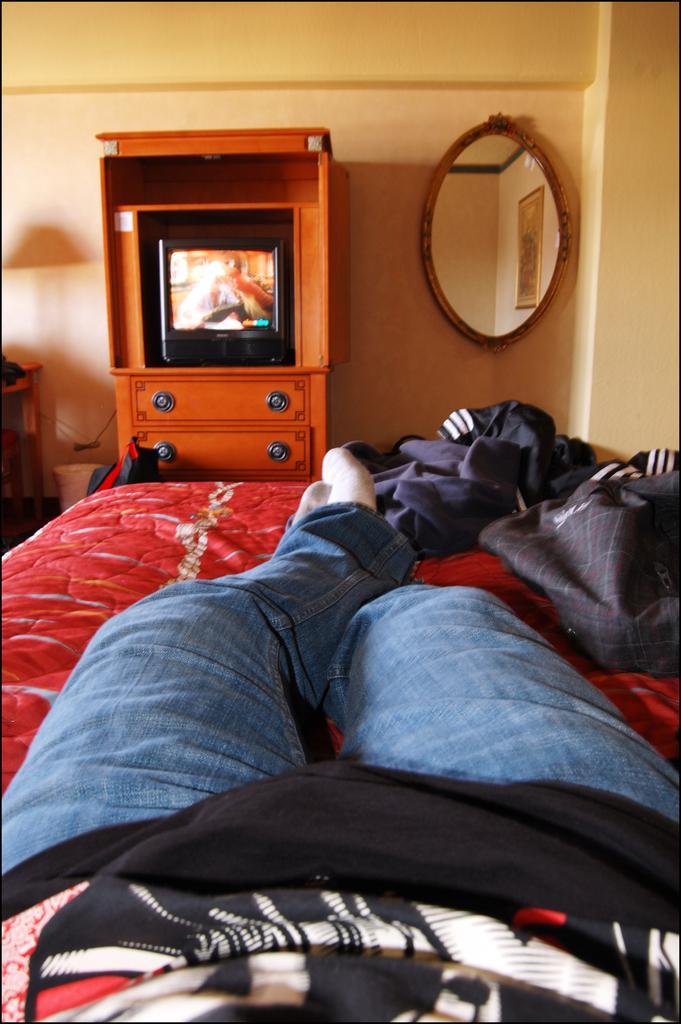In one or two sentences, can you explain what this image depicts? In this picture we can see the legs of a person and some clothes on the bed. We can see a television, wooden object and some objects on the ground. There is a mirror on the wall. In this mirror, we can see the reflection of a frame visible on the wall. We can see the reflections of some objects on the wall. 